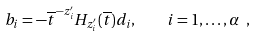Convert formula to latex. <formula><loc_0><loc_0><loc_500><loc_500>b _ { i } = - \overline { t } ^ { - z ^ { \prime } _ { i } } H _ { z ^ { \prime } _ { i } } ( \overline { t } ) d _ { i } , \quad i = 1 , \dots , \alpha \ ,</formula> 